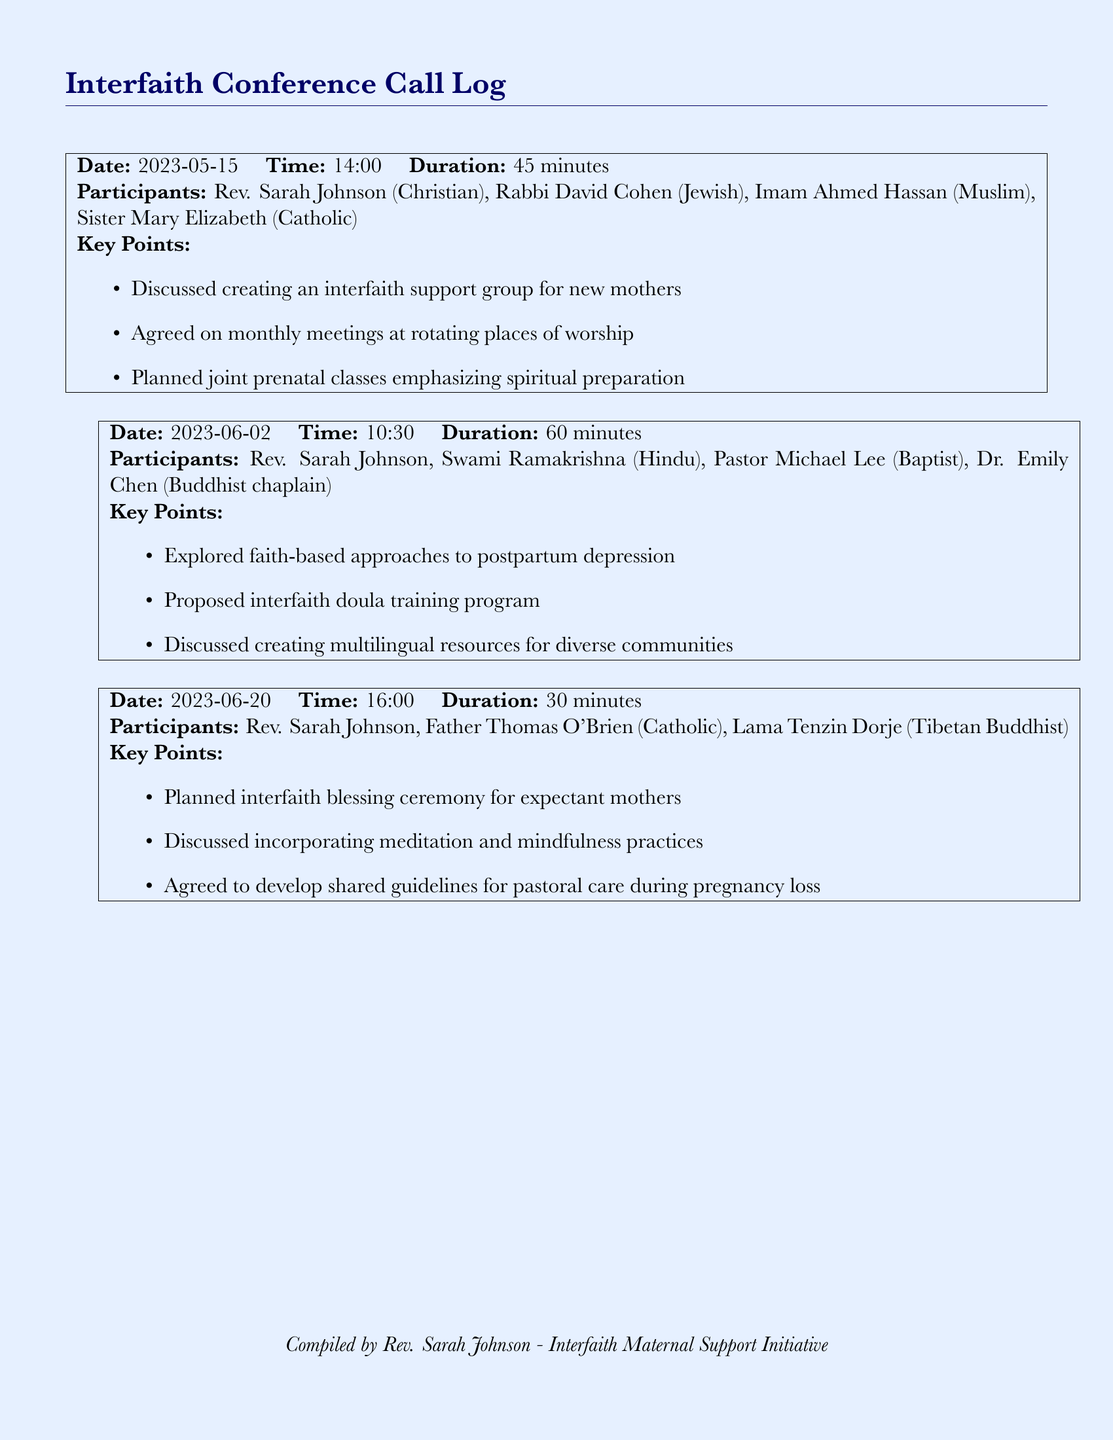What was the date of the first conference call? The date of the first conference call is found in the document's header.
Answer: 2023-05-15 Who participated in the second conference call? The list of participants in the second conference call is specified in the document under that call's details.
Answer: Rev. Sarah Johnson, Swami Ramakrishna, Pastor Michael Lee, Dr. Emily Chen What was the main focus of the third conference call? The main focus is indicated in the key points listed for that particular call.
Answer: Interfaith blessing ceremony for expectant mothers How long did the second conference call last? The duration of the second conference call is mentioned directly in the document.
Answer: 60 minutes Which religious leader is associated with the Catholic faith? The document mentions the names and their corresponding faiths, allowing for identification.
Answer: Father Thomas O'Brien What type of classes were planned in the first call? The document lists key points discussed in the first call, revealing information about the classes.
Answer: Joint prenatal classes How many conference calls are recorded in the document? The number of recorded conference calls can be determined by counting the sections in the document.
Answer: Three What was discussed in regard to postpartum depression? The document provides insights in the key points of the second call regarding this topic.
Answer: Faith-based approaches Where did the meetings agree to take place? The meetings' location decision is highlighted in the key points of the first call.
Answer: Rotating places of worship 